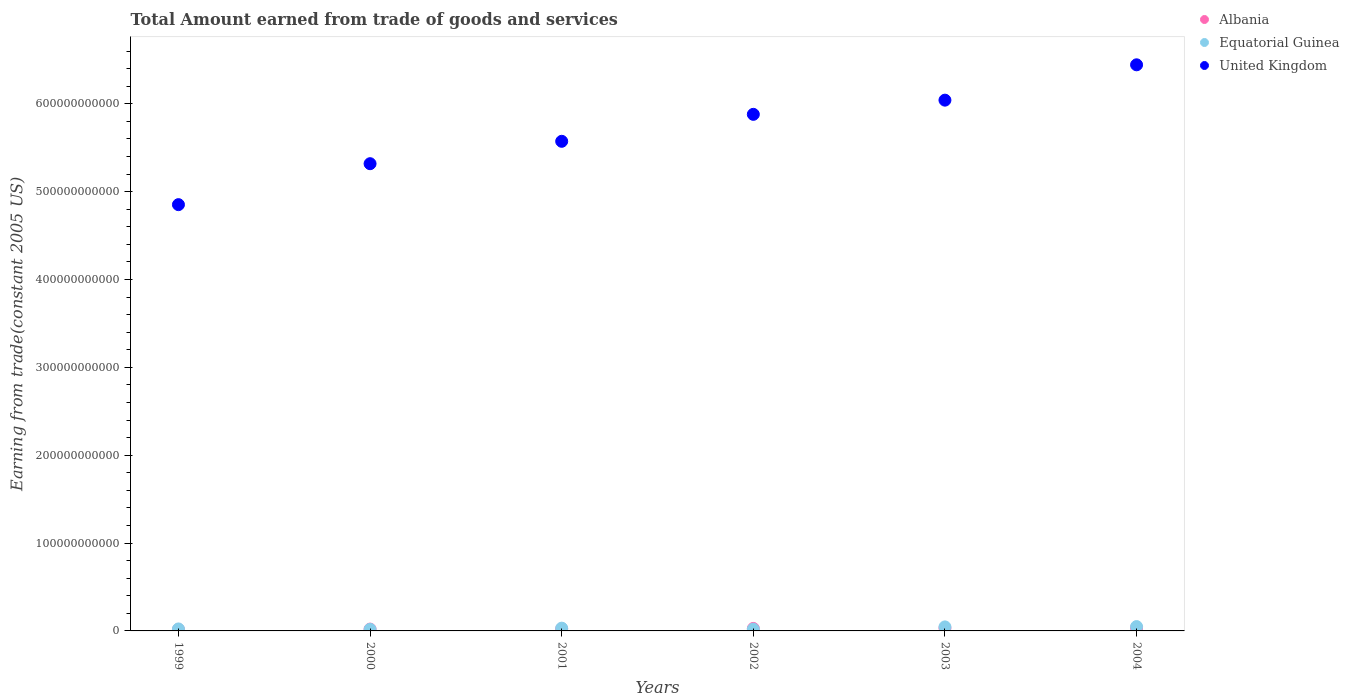What is the total amount earned by trading goods and services in Albania in 2001?
Your answer should be compact. 2.28e+09. Across all years, what is the maximum total amount earned by trading goods and services in United Kingdom?
Offer a very short reply. 6.44e+11. Across all years, what is the minimum total amount earned by trading goods and services in Equatorial Guinea?
Provide a short and direct response. 1.82e+09. In which year was the total amount earned by trading goods and services in United Kingdom minimum?
Keep it short and to the point. 1999. What is the total total amount earned by trading goods and services in United Kingdom in the graph?
Provide a short and direct response. 3.41e+12. What is the difference between the total amount earned by trading goods and services in Equatorial Guinea in 2001 and that in 2004?
Give a very brief answer. -1.79e+09. What is the difference between the total amount earned by trading goods and services in Equatorial Guinea in 2004 and the total amount earned by trading goods and services in Albania in 2000?
Provide a short and direct response. 2.84e+09. What is the average total amount earned by trading goods and services in Equatorial Guinea per year?
Your answer should be compact. 3.12e+09. In the year 2003, what is the difference between the total amount earned by trading goods and services in Albania and total amount earned by trading goods and services in United Kingdom?
Offer a very short reply. -6.01e+11. What is the ratio of the total amount earned by trading goods and services in United Kingdom in 1999 to that in 2001?
Provide a short and direct response. 0.87. Is the total amount earned by trading goods and services in Albania in 2000 less than that in 2004?
Offer a very short reply. Yes. Is the difference between the total amount earned by trading goods and services in Albania in 2003 and 2004 greater than the difference between the total amount earned by trading goods and services in United Kingdom in 2003 and 2004?
Your answer should be compact. Yes. What is the difference between the highest and the second highest total amount earned by trading goods and services in United Kingdom?
Give a very brief answer. 4.02e+1. What is the difference between the highest and the lowest total amount earned by trading goods and services in United Kingdom?
Make the answer very short. 1.59e+11. Is the total amount earned by trading goods and services in Equatorial Guinea strictly greater than the total amount earned by trading goods and services in United Kingdom over the years?
Keep it short and to the point. No. Is the total amount earned by trading goods and services in Equatorial Guinea strictly less than the total amount earned by trading goods and services in Albania over the years?
Provide a short and direct response. No. What is the difference between two consecutive major ticks on the Y-axis?
Provide a short and direct response. 1.00e+11. Where does the legend appear in the graph?
Your answer should be very brief. Top right. What is the title of the graph?
Keep it short and to the point. Total Amount earned from trade of goods and services. What is the label or title of the X-axis?
Offer a terse response. Years. What is the label or title of the Y-axis?
Ensure brevity in your answer.  Earning from trade(constant 2005 US). What is the Earning from trade(constant 2005 US) in Albania in 1999?
Offer a very short reply. 1.61e+09. What is the Earning from trade(constant 2005 US) in Equatorial Guinea in 1999?
Give a very brief answer. 2.26e+09. What is the Earning from trade(constant 2005 US) in United Kingdom in 1999?
Provide a short and direct response. 4.85e+11. What is the Earning from trade(constant 2005 US) of Albania in 2000?
Your answer should be compact. 2.09e+09. What is the Earning from trade(constant 2005 US) of Equatorial Guinea in 2000?
Ensure brevity in your answer.  1.82e+09. What is the Earning from trade(constant 2005 US) of United Kingdom in 2000?
Offer a terse response. 5.32e+11. What is the Earning from trade(constant 2005 US) in Albania in 2001?
Keep it short and to the point. 2.28e+09. What is the Earning from trade(constant 2005 US) of Equatorial Guinea in 2001?
Keep it short and to the point. 3.14e+09. What is the Earning from trade(constant 2005 US) in United Kingdom in 2001?
Give a very brief answer. 5.57e+11. What is the Earning from trade(constant 2005 US) in Albania in 2002?
Offer a very short reply. 2.83e+09. What is the Earning from trade(constant 2005 US) of Equatorial Guinea in 2002?
Your answer should be very brief. 1.99e+09. What is the Earning from trade(constant 2005 US) of United Kingdom in 2002?
Offer a terse response. 5.88e+11. What is the Earning from trade(constant 2005 US) of Albania in 2003?
Offer a very short reply. 3.19e+09. What is the Earning from trade(constant 2005 US) of Equatorial Guinea in 2003?
Give a very brief answer. 4.59e+09. What is the Earning from trade(constant 2005 US) in United Kingdom in 2003?
Offer a terse response. 6.04e+11. What is the Earning from trade(constant 2005 US) in Albania in 2004?
Your response must be concise. 3.40e+09. What is the Earning from trade(constant 2005 US) in Equatorial Guinea in 2004?
Your answer should be very brief. 4.93e+09. What is the Earning from trade(constant 2005 US) of United Kingdom in 2004?
Give a very brief answer. 6.44e+11. Across all years, what is the maximum Earning from trade(constant 2005 US) in Albania?
Offer a terse response. 3.40e+09. Across all years, what is the maximum Earning from trade(constant 2005 US) in Equatorial Guinea?
Keep it short and to the point. 4.93e+09. Across all years, what is the maximum Earning from trade(constant 2005 US) of United Kingdom?
Give a very brief answer. 6.44e+11. Across all years, what is the minimum Earning from trade(constant 2005 US) in Albania?
Provide a succinct answer. 1.61e+09. Across all years, what is the minimum Earning from trade(constant 2005 US) of Equatorial Guinea?
Ensure brevity in your answer.  1.82e+09. Across all years, what is the minimum Earning from trade(constant 2005 US) of United Kingdom?
Your answer should be very brief. 4.85e+11. What is the total Earning from trade(constant 2005 US) of Albania in the graph?
Provide a succinct answer. 1.54e+1. What is the total Earning from trade(constant 2005 US) of Equatorial Guinea in the graph?
Offer a very short reply. 1.87e+1. What is the total Earning from trade(constant 2005 US) in United Kingdom in the graph?
Your answer should be compact. 3.41e+12. What is the difference between the Earning from trade(constant 2005 US) of Albania in 1999 and that in 2000?
Your answer should be compact. -4.80e+08. What is the difference between the Earning from trade(constant 2005 US) in Equatorial Guinea in 1999 and that in 2000?
Offer a terse response. 4.34e+08. What is the difference between the Earning from trade(constant 2005 US) in United Kingdom in 1999 and that in 2000?
Offer a terse response. -4.66e+1. What is the difference between the Earning from trade(constant 2005 US) of Albania in 1999 and that in 2001?
Provide a short and direct response. -6.62e+08. What is the difference between the Earning from trade(constant 2005 US) in Equatorial Guinea in 1999 and that in 2001?
Provide a succinct answer. -8.82e+08. What is the difference between the Earning from trade(constant 2005 US) of United Kingdom in 1999 and that in 2001?
Offer a terse response. -7.21e+1. What is the difference between the Earning from trade(constant 2005 US) in Albania in 1999 and that in 2002?
Offer a terse response. -1.22e+09. What is the difference between the Earning from trade(constant 2005 US) in Equatorial Guinea in 1999 and that in 2002?
Provide a short and direct response. 2.64e+08. What is the difference between the Earning from trade(constant 2005 US) in United Kingdom in 1999 and that in 2002?
Your answer should be compact. -1.03e+11. What is the difference between the Earning from trade(constant 2005 US) of Albania in 1999 and that in 2003?
Provide a succinct answer. -1.58e+09. What is the difference between the Earning from trade(constant 2005 US) of Equatorial Guinea in 1999 and that in 2003?
Provide a short and direct response. -2.33e+09. What is the difference between the Earning from trade(constant 2005 US) of United Kingdom in 1999 and that in 2003?
Give a very brief answer. -1.19e+11. What is the difference between the Earning from trade(constant 2005 US) of Albania in 1999 and that in 2004?
Your response must be concise. -1.78e+09. What is the difference between the Earning from trade(constant 2005 US) of Equatorial Guinea in 1999 and that in 2004?
Offer a very short reply. -2.68e+09. What is the difference between the Earning from trade(constant 2005 US) of United Kingdom in 1999 and that in 2004?
Keep it short and to the point. -1.59e+11. What is the difference between the Earning from trade(constant 2005 US) of Albania in 2000 and that in 2001?
Ensure brevity in your answer.  -1.82e+08. What is the difference between the Earning from trade(constant 2005 US) of Equatorial Guinea in 2000 and that in 2001?
Your response must be concise. -1.32e+09. What is the difference between the Earning from trade(constant 2005 US) in United Kingdom in 2000 and that in 2001?
Provide a short and direct response. -2.55e+1. What is the difference between the Earning from trade(constant 2005 US) in Albania in 2000 and that in 2002?
Keep it short and to the point. -7.39e+08. What is the difference between the Earning from trade(constant 2005 US) of Equatorial Guinea in 2000 and that in 2002?
Ensure brevity in your answer.  -1.69e+08. What is the difference between the Earning from trade(constant 2005 US) in United Kingdom in 2000 and that in 2002?
Keep it short and to the point. -5.62e+1. What is the difference between the Earning from trade(constant 2005 US) in Albania in 2000 and that in 2003?
Keep it short and to the point. -1.10e+09. What is the difference between the Earning from trade(constant 2005 US) in Equatorial Guinea in 2000 and that in 2003?
Offer a terse response. -2.76e+09. What is the difference between the Earning from trade(constant 2005 US) in United Kingdom in 2000 and that in 2003?
Offer a terse response. -7.23e+1. What is the difference between the Earning from trade(constant 2005 US) of Albania in 2000 and that in 2004?
Make the answer very short. -1.30e+09. What is the difference between the Earning from trade(constant 2005 US) in Equatorial Guinea in 2000 and that in 2004?
Your response must be concise. -3.11e+09. What is the difference between the Earning from trade(constant 2005 US) in United Kingdom in 2000 and that in 2004?
Offer a terse response. -1.13e+11. What is the difference between the Earning from trade(constant 2005 US) of Albania in 2001 and that in 2002?
Make the answer very short. -5.57e+08. What is the difference between the Earning from trade(constant 2005 US) in Equatorial Guinea in 2001 and that in 2002?
Offer a terse response. 1.15e+09. What is the difference between the Earning from trade(constant 2005 US) of United Kingdom in 2001 and that in 2002?
Provide a short and direct response. -3.07e+1. What is the difference between the Earning from trade(constant 2005 US) of Albania in 2001 and that in 2003?
Provide a short and direct response. -9.16e+08. What is the difference between the Earning from trade(constant 2005 US) in Equatorial Guinea in 2001 and that in 2003?
Make the answer very short. -1.45e+09. What is the difference between the Earning from trade(constant 2005 US) of United Kingdom in 2001 and that in 2003?
Ensure brevity in your answer.  -4.68e+1. What is the difference between the Earning from trade(constant 2005 US) of Albania in 2001 and that in 2004?
Your response must be concise. -1.12e+09. What is the difference between the Earning from trade(constant 2005 US) of Equatorial Guinea in 2001 and that in 2004?
Offer a terse response. -1.79e+09. What is the difference between the Earning from trade(constant 2005 US) in United Kingdom in 2001 and that in 2004?
Give a very brief answer. -8.71e+1. What is the difference between the Earning from trade(constant 2005 US) of Albania in 2002 and that in 2003?
Your answer should be very brief. -3.60e+08. What is the difference between the Earning from trade(constant 2005 US) of Equatorial Guinea in 2002 and that in 2003?
Offer a terse response. -2.59e+09. What is the difference between the Earning from trade(constant 2005 US) of United Kingdom in 2002 and that in 2003?
Offer a very short reply. -1.61e+1. What is the difference between the Earning from trade(constant 2005 US) of Albania in 2002 and that in 2004?
Provide a short and direct response. -5.65e+08. What is the difference between the Earning from trade(constant 2005 US) of Equatorial Guinea in 2002 and that in 2004?
Your response must be concise. -2.94e+09. What is the difference between the Earning from trade(constant 2005 US) of United Kingdom in 2002 and that in 2004?
Ensure brevity in your answer.  -5.64e+1. What is the difference between the Earning from trade(constant 2005 US) in Albania in 2003 and that in 2004?
Your answer should be very brief. -2.05e+08. What is the difference between the Earning from trade(constant 2005 US) of Equatorial Guinea in 2003 and that in 2004?
Keep it short and to the point. -3.49e+08. What is the difference between the Earning from trade(constant 2005 US) in United Kingdom in 2003 and that in 2004?
Offer a terse response. -4.02e+1. What is the difference between the Earning from trade(constant 2005 US) in Albania in 1999 and the Earning from trade(constant 2005 US) in Equatorial Guinea in 2000?
Provide a succinct answer. -2.10e+08. What is the difference between the Earning from trade(constant 2005 US) of Albania in 1999 and the Earning from trade(constant 2005 US) of United Kingdom in 2000?
Your response must be concise. -5.30e+11. What is the difference between the Earning from trade(constant 2005 US) in Equatorial Guinea in 1999 and the Earning from trade(constant 2005 US) in United Kingdom in 2000?
Your response must be concise. -5.30e+11. What is the difference between the Earning from trade(constant 2005 US) of Albania in 1999 and the Earning from trade(constant 2005 US) of Equatorial Guinea in 2001?
Ensure brevity in your answer.  -1.53e+09. What is the difference between the Earning from trade(constant 2005 US) in Albania in 1999 and the Earning from trade(constant 2005 US) in United Kingdom in 2001?
Offer a very short reply. -5.56e+11. What is the difference between the Earning from trade(constant 2005 US) in Equatorial Guinea in 1999 and the Earning from trade(constant 2005 US) in United Kingdom in 2001?
Your response must be concise. -5.55e+11. What is the difference between the Earning from trade(constant 2005 US) of Albania in 1999 and the Earning from trade(constant 2005 US) of Equatorial Guinea in 2002?
Ensure brevity in your answer.  -3.80e+08. What is the difference between the Earning from trade(constant 2005 US) of Albania in 1999 and the Earning from trade(constant 2005 US) of United Kingdom in 2002?
Offer a terse response. -5.86e+11. What is the difference between the Earning from trade(constant 2005 US) in Equatorial Guinea in 1999 and the Earning from trade(constant 2005 US) in United Kingdom in 2002?
Your answer should be very brief. -5.86e+11. What is the difference between the Earning from trade(constant 2005 US) of Albania in 1999 and the Earning from trade(constant 2005 US) of Equatorial Guinea in 2003?
Ensure brevity in your answer.  -2.97e+09. What is the difference between the Earning from trade(constant 2005 US) of Albania in 1999 and the Earning from trade(constant 2005 US) of United Kingdom in 2003?
Offer a very short reply. -6.03e+11. What is the difference between the Earning from trade(constant 2005 US) of Equatorial Guinea in 1999 and the Earning from trade(constant 2005 US) of United Kingdom in 2003?
Give a very brief answer. -6.02e+11. What is the difference between the Earning from trade(constant 2005 US) of Albania in 1999 and the Earning from trade(constant 2005 US) of Equatorial Guinea in 2004?
Give a very brief answer. -3.32e+09. What is the difference between the Earning from trade(constant 2005 US) of Albania in 1999 and the Earning from trade(constant 2005 US) of United Kingdom in 2004?
Keep it short and to the point. -6.43e+11. What is the difference between the Earning from trade(constant 2005 US) of Equatorial Guinea in 1999 and the Earning from trade(constant 2005 US) of United Kingdom in 2004?
Make the answer very short. -6.42e+11. What is the difference between the Earning from trade(constant 2005 US) in Albania in 2000 and the Earning from trade(constant 2005 US) in Equatorial Guinea in 2001?
Offer a very short reply. -1.05e+09. What is the difference between the Earning from trade(constant 2005 US) in Albania in 2000 and the Earning from trade(constant 2005 US) in United Kingdom in 2001?
Ensure brevity in your answer.  -5.55e+11. What is the difference between the Earning from trade(constant 2005 US) of Equatorial Guinea in 2000 and the Earning from trade(constant 2005 US) of United Kingdom in 2001?
Ensure brevity in your answer.  -5.55e+11. What is the difference between the Earning from trade(constant 2005 US) in Albania in 2000 and the Earning from trade(constant 2005 US) in Equatorial Guinea in 2002?
Provide a short and direct response. 1.00e+08. What is the difference between the Earning from trade(constant 2005 US) of Albania in 2000 and the Earning from trade(constant 2005 US) of United Kingdom in 2002?
Your response must be concise. -5.86e+11. What is the difference between the Earning from trade(constant 2005 US) in Equatorial Guinea in 2000 and the Earning from trade(constant 2005 US) in United Kingdom in 2002?
Offer a terse response. -5.86e+11. What is the difference between the Earning from trade(constant 2005 US) of Albania in 2000 and the Earning from trade(constant 2005 US) of Equatorial Guinea in 2003?
Offer a very short reply. -2.49e+09. What is the difference between the Earning from trade(constant 2005 US) in Albania in 2000 and the Earning from trade(constant 2005 US) in United Kingdom in 2003?
Your answer should be compact. -6.02e+11. What is the difference between the Earning from trade(constant 2005 US) of Equatorial Guinea in 2000 and the Earning from trade(constant 2005 US) of United Kingdom in 2003?
Your response must be concise. -6.02e+11. What is the difference between the Earning from trade(constant 2005 US) in Albania in 2000 and the Earning from trade(constant 2005 US) in Equatorial Guinea in 2004?
Make the answer very short. -2.84e+09. What is the difference between the Earning from trade(constant 2005 US) of Albania in 2000 and the Earning from trade(constant 2005 US) of United Kingdom in 2004?
Make the answer very short. -6.42e+11. What is the difference between the Earning from trade(constant 2005 US) in Equatorial Guinea in 2000 and the Earning from trade(constant 2005 US) in United Kingdom in 2004?
Provide a short and direct response. -6.43e+11. What is the difference between the Earning from trade(constant 2005 US) of Albania in 2001 and the Earning from trade(constant 2005 US) of Equatorial Guinea in 2002?
Offer a very short reply. 2.82e+08. What is the difference between the Earning from trade(constant 2005 US) of Albania in 2001 and the Earning from trade(constant 2005 US) of United Kingdom in 2002?
Offer a very short reply. -5.86e+11. What is the difference between the Earning from trade(constant 2005 US) in Equatorial Guinea in 2001 and the Earning from trade(constant 2005 US) in United Kingdom in 2002?
Your answer should be very brief. -5.85e+11. What is the difference between the Earning from trade(constant 2005 US) of Albania in 2001 and the Earning from trade(constant 2005 US) of Equatorial Guinea in 2003?
Give a very brief answer. -2.31e+09. What is the difference between the Earning from trade(constant 2005 US) in Albania in 2001 and the Earning from trade(constant 2005 US) in United Kingdom in 2003?
Keep it short and to the point. -6.02e+11. What is the difference between the Earning from trade(constant 2005 US) of Equatorial Guinea in 2001 and the Earning from trade(constant 2005 US) of United Kingdom in 2003?
Keep it short and to the point. -6.01e+11. What is the difference between the Earning from trade(constant 2005 US) of Albania in 2001 and the Earning from trade(constant 2005 US) of Equatorial Guinea in 2004?
Make the answer very short. -2.66e+09. What is the difference between the Earning from trade(constant 2005 US) of Albania in 2001 and the Earning from trade(constant 2005 US) of United Kingdom in 2004?
Offer a terse response. -6.42e+11. What is the difference between the Earning from trade(constant 2005 US) in Equatorial Guinea in 2001 and the Earning from trade(constant 2005 US) in United Kingdom in 2004?
Provide a succinct answer. -6.41e+11. What is the difference between the Earning from trade(constant 2005 US) of Albania in 2002 and the Earning from trade(constant 2005 US) of Equatorial Guinea in 2003?
Your answer should be compact. -1.75e+09. What is the difference between the Earning from trade(constant 2005 US) of Albania in 2002 and the Earning from trade(constant 2005 US) of United Kingdom in 2003?
Your answer should be compact. -6.01e+11. What is the difference between the Earning from trade(constant 2005 US) of Equatorial Guinea in 2002 and the Earning from trade(constant 2005 US) of United Kingdom in 2003?
Offer a very short reply. -6.02e+11. What is the difference between the Earning from trade(constant 2005 US) in Albania in 2002 and the Earning from trade(constant 2005 US) in Equatorial Guinea in 2004?
Offer a very short reply. -2.10e+09. What is the difference between the Earning from trade(constant 2005 US) in Albania in 2002 and the Earning from trade(constant 2005 US) in United Kingdom in 2004?
Ensure brevity in your answer.  -6.42e+11. What is the difference between the Earning from trade(constant 2005 US) of Equatorial Guinea in 2002 and the Earning from trade(constant 2005 US) of United Kingdom in 2004?
Give a very brief answer. -6.42e+11. What is the difference between the Earning from trade(constant 2005 US) of Albania in 2003 and the Earning from trade(constant 2005 US) of Equatorial Guinea in 2004?
Your response must be concise. -1.74e+09. What is the difference between the Earning from trade(constant 2005 US) of Albania in 2003 and the Earning from trade(constant 2005 US) of United Kingdom in 2004?
Provide a succinct answer. -6.41e+11. What is the difference between the Earning from trade(constant 2005 US) of Equatorial Guinea in 2003 and the Earning from trade(constant 2005 US) of United Kingdom in 2004?
Provide a succinct answer. -6.40e+11. What is the average Earning from trade(constant 2005 US) in Albania per year?
Your response must be concise. 2.57e+09. What is the average Earning from trade(constant 2005 US) in Equatorial Guinea per year?
Ensure brevity in your answer.  3.12e+09. What is the average Earning from trade(constant 2005 US) of United Kingdom per year?
Provide a succinct answer. 5.68e+11. In the year 1999, what is the difference between the Earning from trade(constant 2005 US) in Albania and Earning from trade(constant 2005 US) in Equatorial Guinea?
Offer a very short reply. -6.44e+08. In the year 1999, what is the difference between the Earning from trade(constant 2005 US) of Albania and Earning from trade(constant 2005 US) of United Kingdom?
Offer a terse response. -4.84e+11. In the year 1999, what is the difference between the Earning from trade(constant 2005 US) in Equatorial Guinea and Earning from trade(constant 2005 US) in United Kingdom?
Your answer should be very brief. -4.83e+11. In the year 2000, what is the difference between the Earning from trade(constant 2005 US) in Albania and Earning from trade(constant 2005 US) in Equatorial Guinea?
Provide a succinct answer. 2.69e+08. In the year 2000, what is the difference between the Earning from trade(constant 2005 US) in Albania and Earning from trade(constant 2005 US) in United Kingdom?
Keep it short and to the point. -5.30e+11. In the year 2000, what is the difference between the Earning from trade(constant 2005 US) in Equatorial Guinea and Earning from trade(constant 2005 US) in United Kingdom?
Keep it short and to the point. -5.30e+11. In the year 2001, what is the difference between the Earning from trade(constant 2005 US) of Albania and Earning from trade(constant 2005 US) of Equatorial Guinea?
Offer a very short reply. -8.64e+08. In the year 2001, what is the difference between the Earning from trade(constant 2005 US) in Albania and Earning from trade(constant 2005 US) in United Kingdom?
Provide a short and direct response. -5.55e+11. In the year 2001, what is the difference between the Earning from trade(constant 2005 US) of Equatorial Guinea and Earning from trade(constant 2005 US) of United Kingdom?
Your answer should be very brief. -5.54e+11. In the year 2002, what is the difference between the Earning from trade(constant 2005 US) of Albania and Earning from trade(constant 2005 US) of Equatorial Guinea?
Offer a very short reply. 8.39e+08. In the year 2002, what is the difference between the Earning from trade(constant 2005 US) in Albania and Earning from trade(constant 2005 US) in United Kingdom?
Your answer should be compact. -5.85e+11. In the year 2002, what is the difference between the Earning from trade(constant 2005 US) of Equatorial Guinea and Earning from trade(constant 2005 US) of United Kingdom?
Provide a succinct answer. -5.86e+11. In the year 2003, what is the difference between the Earning from trade(constant 2005 US) in Albania and Earning from trade(constant 2005 US) in Equatorial Guinea?
Your answer should be compact. -1.39e+09. In the year 2003, what is the difference between the Earning from trade(constant 2005 US) in Albania and Earning from trade(constant 2005 US) in United Kingdom?
Offer a terse response. -6.01e+11. In the year 2003, what is the difference between the Earning from trade(constant 2005 US) of Equatorial Guinea and Earning from trade(constant 2005 US) of United Kingdom?
Your response must be concise. -6.00e+11. In the year 2004, what is the difference between the Earning from trade(constant 2005 US) of Albania and Earning from trade(constant 2005 US) of Equatorial Guinea?
Keep it short and to the point. -1.54e+09. In the year 2004, what is the difference between the Earning from trade(constant 2005 US) of Albania and Earning from trade(constant 2005 US) of United Kingdom?
Your answer should be very brief. -6.41e+11. In the year 2004, what is the difference between the Earning from trade(constant 2005 US) of Equatorial Guinea and Earning from trade(constant 2005 US) of United Kingdom?
Give a very brief answer. -6.39e+11. What is the ratio of the Earning from trade(constant 2005 US) in Albania in 1999 to that in 2000?
Your answer should be compact. 0.77. What is the ratio of the Earning from trade(constant 2005 US) of Equatorial Guinea in 1999 to that in 2000?
Your answer should be very brief. 1.24. What is the ratio of the Earning from trade(constant 2005 US) in United Kingdom in 1999 to that in 2000?
Your response must be concise. 0.91. What is the ratio of the Earning from trade(constant 2005 US) in Albania in 1999 to that in 2001?
Give a very brief answer. 0.71. What is the ratio of the Earning from trade(constant 2005 US) in Equatorial Guinea in 1999 to that in 2001?
Make the answer very short. 0.72. What is the ratio of the Earning from trade(constant 2005 US) of United Kingdom in 1999 to that in 2001?
Your answer should be very brief. 0.87. What is the ratio of the Earning from trade(constant 2005 US) of Albania in 1999 to that in 2002?
Your answer should be compact. 0.57. What is the ratio of the Earning from trade(constant 2005 US) in Equatorial Guinea in 1999 to that in 2002?
Keep it short and to the point. 1.13. What is the ratio of the Earning from trade(constant 2005 US) of United Kingdom in 1999 to that in 2002?
Give a very brief answer. 0.83. What is the ratio of the Earning from trade(constant 2005 US) in Albania in 1999 to that in 2003?
Ensure brevity in your answer.  0.51. What is the ratio of the Earning from trade(constant 2005 US) of Equatorial Guinea in 1999 to that in 2003?
Keep it short and to the point. 0.49. What is the ratio of the Earning from trade(constant 2005 US) of United Kingdom in 1999 to that in 2003?
Make the answer very short. 0.8. What is the ratio of the Earning from trade(constant 2005 US) of Albania in 1999 to that in 2004?
Offer a very short reply. 0.48. What is the ratio of the Earning from trade(constant 2005 US) of Equatorial Guinea in 1999 to that in 2004?
Give a very brief answer. 0.46. What is the ratio of the Earning from trade(constant 2005 US) of United Kingdom in 1999 to that in 2004?
Keep it short and to the point. 0.75. What is the ratio of the Earning from trade(constant 2005 US) of Albania in 2000 to that in 2001?
Ensure brevity in your answer.  0.92. What is the ratio of the Earning from trade(constant 2005 US) in Equatorial Guinea in 2000 to that in 2001?
Keep it short and to the point. 0.58. What is the ratio of the Earning from trade(constant 2005 US) in United Kingdom in 2000 to that in 2001?
Your answer should be compact. 0.95. What is the ratio of the Earning from trade(constant 2005 US) of Albania in 2000 to that in 2002?
Offer a terse response. 0.74. What is the ratio of the Earning from trade(constant 2005 US) of Equatorial Guinea in 2000 to that in 2002?
Keep it short and to the point. 0.92. What is the ratio of the Earning from trade(constant 2005 US) in United Kingdom in 2000 to that in 2002?
Provide a succinct answer. 0.9. What is the ratio of the Earning from trade(constant 2005 US) of Albania in 2000 to that in 2003?
Keep it short and to the point. 0.66. What is the ratio of the Earning from trade(constant 2005 US) of Equatorial Guinea in 2000 to that in 2003?
Give a very brief answer. 0.4. What is the ratio of the Earning from trade(constant 2005 US) of United Kingdom in 2000 to that in 2003?
Make the answer very short. 0.88. What is the ratio of the Earning from trade(constant 2005 US) of Albania in 2000 to that in 2004?
Provide a short and direct response. 0.62. What is the ratio of the Earning from trade(constant 2005 US) of Equatorial Guinea in 2000 to that in 2004?
Your answer should be compact. 0.37. What is the ratio of the Earning from trade(constant 2005 US) in United Kingdom in 2000 to that in 2004?
Give a very brief answer. 0.83. What is the ratio of the Earning from trade(constant 2005 US) in Albania in 2001 to that in 2002?
Ensure brevity in your answer.  0.8. What is the ratio of the Earning from trade(constant 2005 US) in Equatorial Guinea in 2001 to that in 2002?
Your response must be concise. 1.57. What is the ratio of the Earning from trade(constant 2005 US) of United Kingdom in 2001 to that in 2002?
Keep it short and to the point. 0.95. What is the ratio of the Earning from trade(constant 2005 US) in Albania in 2001 to that in 2003?
Offer a very short reply. 0.71. What is the ratio of the Earning from trade(constant 2005 US) of Equatorial Guinea in 2001 to that in 2003?
Your answer should be very brief. 0.68. What is the ratio of the Earning from trade(constant 2005 US) in United Kingdom in 2001 to that in 2003?
Provide a short and direct response. 0.92. What is the ratio of the Earning from trade(constant 2005 US) of Albania in 2001 to that in 2004?
Make the answer very short. 0.67. What is the ratio of the Earning from trade(constant 2005 US) of Equatorial Guinea in 2001 to that in 2004?
Make the answer very short. 0.64. What is the ratio of the Earning from trade(constant 2005 US) in United Kingdom in 2001 to that in 2004?
Provide a succinct answer. 0.86. What is the ratio of the Earning from trade(constant 2005 US) of Albania in 2002 to that in 2003?
Your answer should be very brief. 0.89. What is the ratio of the Earning from trade(constant 2005 US) of Equatorial Guinea in 2002 to that in 2003?
Your answer should be very brief. 0.43. What is the ratio of the Earning from trade(constant 2005 US) of United Kingdom in 2002 to that in 2003?
Provide a short and direct response. 0.97. What is the ratio of the Earning from trade(constant 2005 US) of Albania in 2002 to that in 2004?
Provide a succinct answer. 0.83. What is the ratio of the Earning from trade(constant 2005 US) of Equatorial Guinea in 2002 to that in 2004?
Give a very brief answer. 0.4. What is the ratio of the Earning from trade(constant 2005 US) of United Kingdom in 2002 to that in 2004?
Provide a succinct answer. 0.91. What is the ratio of the Earning from trade(constant 2005 US) of Albania in 2003 to that in 2004?
Your answer should be compact. 0.94. What is the ratio of the Earning from trade(constant 2005 US) of Equatorial Guinea in 2003 to that in 2004?
Offer a very short reply. 0.93. What is the ratio of the Earning from trade(constant 2005 US) of United Kingdom in 2003 to that in 2004?
Keep it short and to the point. 0.94. What is the difference between the highest and the second highest Earning from trade(constant 2005 US) of Albania?
Make the answer very short. 2.05e+08. What is the difference between the highest and the second highest Earning from trade(constant 2005 US) in Equatorial Guinea?
Offer a terse response. 3.49e+08. What is the difference between the highest and the second highest Earning from trade(constant 2005 US) of United Kingdom?
Give a very brief answer. 4.02e+1. What is the difference between the highest and the lowest Earning from trade(constant 2005 US) in Albania?
Keep it short and to the point. 1.78e+09. What is the difference between the highest and the lowest Earning from trade(constant 2005 US) of Equatorial Guinea?
Offer a terse response. 3.11e+09. What is the difference between the highest and the lowest Earning from trade(constant 2005 US) of United Kingdom?
Give a very brief answer. 1.59e+11. 